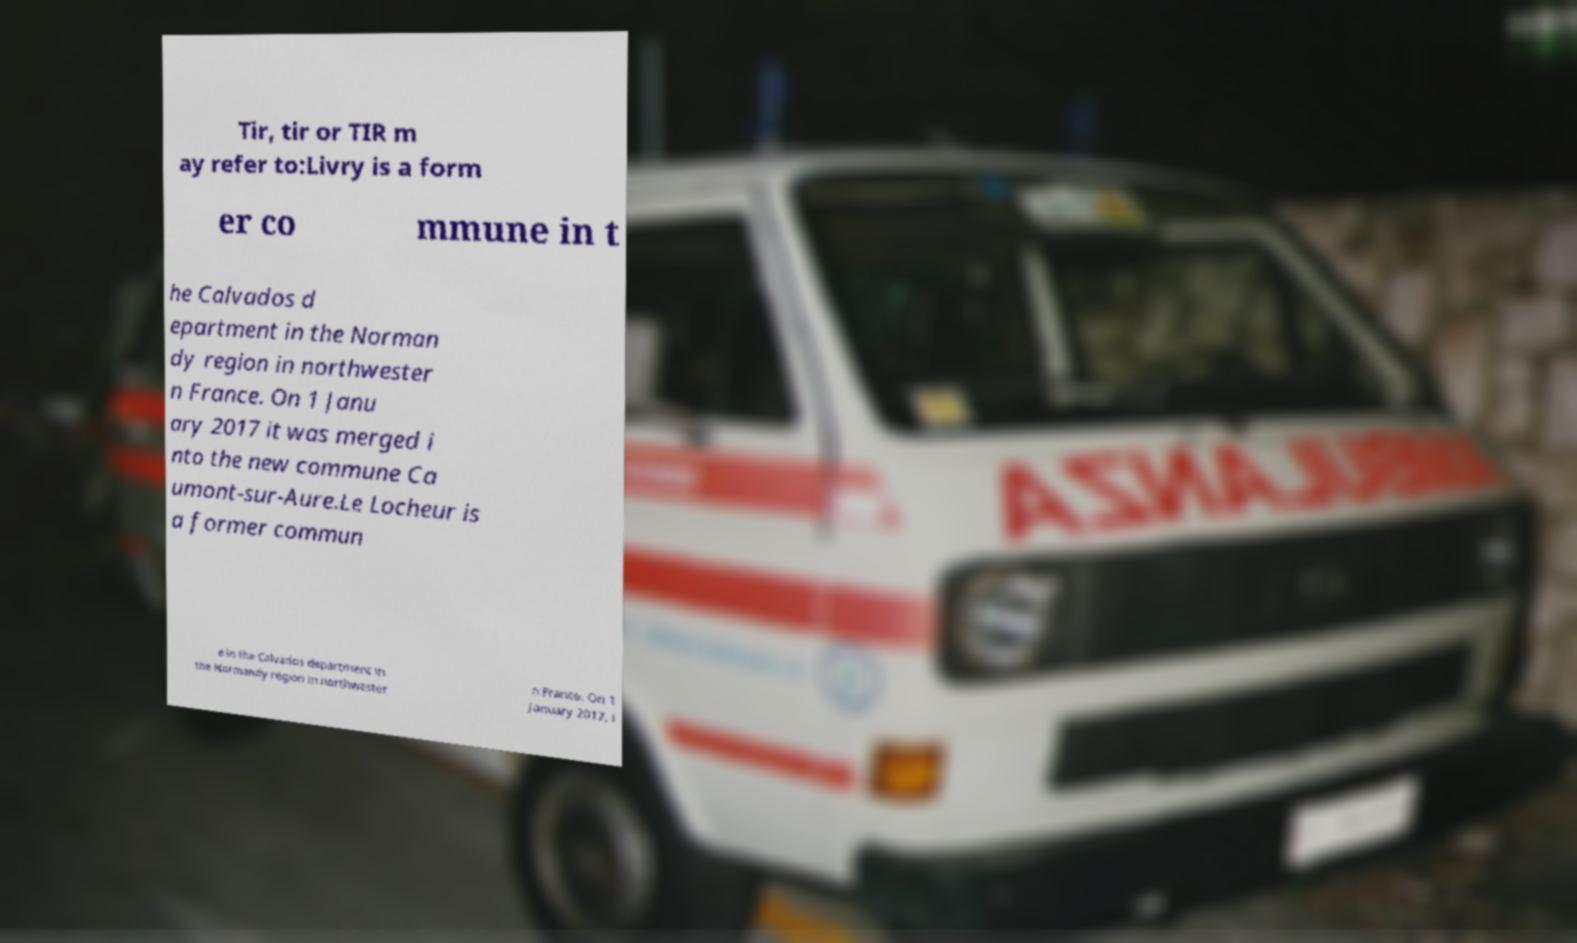Could you assist in decoding the text presented in this image and type it out clearly? Tir, tir or TIR m ay refer to:Livry is a form er co mmune in t he Calvados d epartment in the Norman dy region in northwester n France. On 1 Janu ary 2017 it was merged i nto the new commune Ca umont-sur-Aure.Le Locheur is a former commun e in the Calvados department in the Normandy region in northwester n France. On 1 January 2017, i 